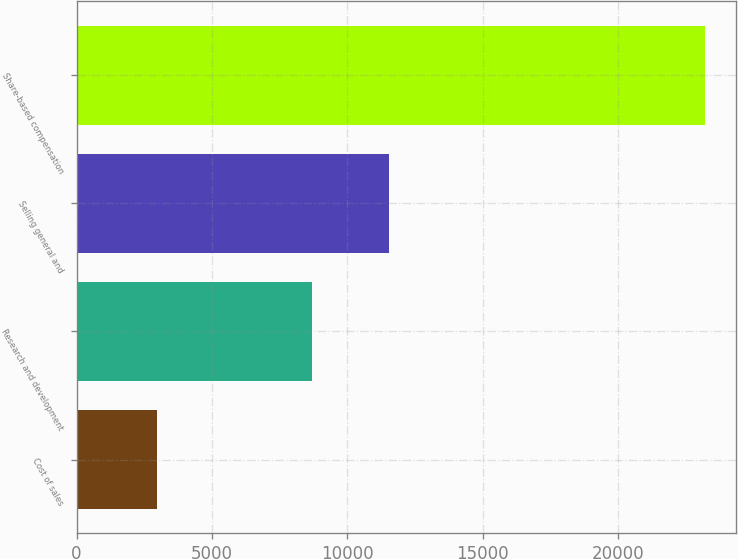Convert chart to OTSL. <chart><loc_0><loc_0><loc_500><loc_500><bar_chart><fcel>Cost of sales<fcel>Research and development<fcel>Selling general and<fcel>Share-based compensation<nl><fcel>2974<fcel>8700<fcel>11538<fcel>23212<nl></chart> 